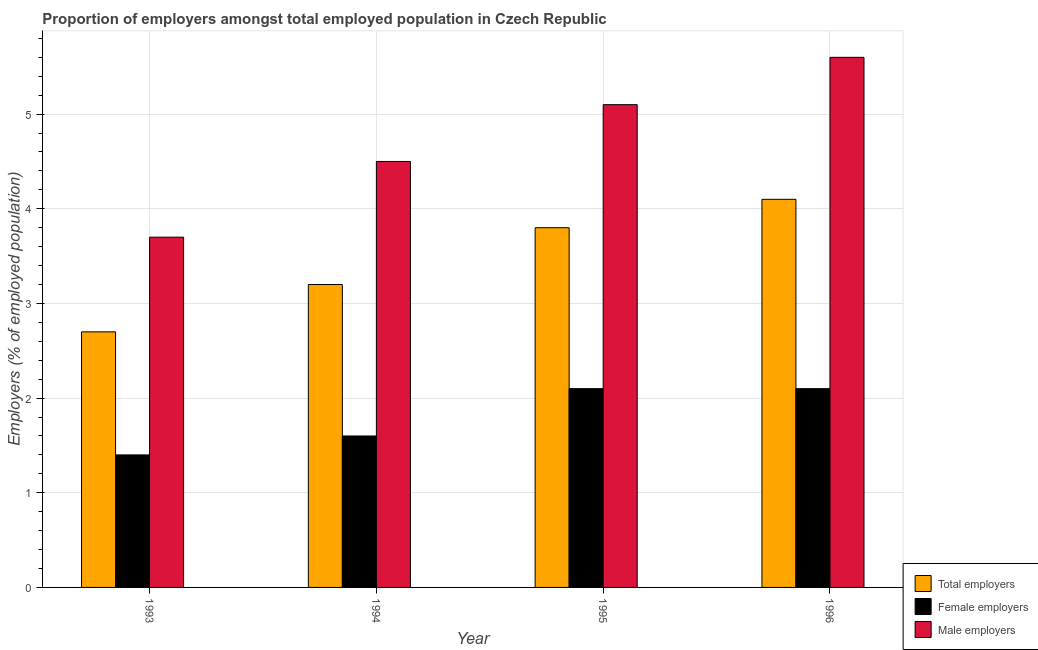How many different coloured bars are there?
Ensure brevity in your answer.  3. How many groups of bars are there?
Ensure brevity in your answer.  4. Are the number of bars per tick equal to the number of legend labels?
Provide a succinct answer. Yes. Are the number of bars on each tick of the X-axis equal?
Keep it short and to the point. Yes. How many bars are there on the 4th tick from the left?
Keep it short and to the point. 3. How many bars are there on the 3rd tick from the right?
Offer a terse response. 3. In how many cases, is the number of bars for a given year not equal to the number of legend labels?
Make the answer very short. 0. What is the percentage of total employers in 1993?
Keep it short and to the point. 2.7. Across all years, what is the maximum percentage of female employers?
Ensure brevity in your answer.  2.1. Across all years, what is the minimum percentage of female employers?
Provide a succinct answer. 1.4. In which year was the percentage of total employers maximum?
Your answer should be compact. 1996. What is the total percentage of total employers in the graph?
Provide a succinct answer. 13.8. What is the difference between the percentage of total employers in 1993 and that in 1996?
Give a very brief answer. -1.4. What is the difference between the percentage of female employers in 1996 and the percentage of total employers in 1994?
Offer a terse response. 0.5. What is the average percentage of total employers per year?
Your answer should be compact. 3.45. In how many years, is the percentage of total employers greater than 4.4 %?
Offer a very short reply. 0. What is the ratio of the percentage of male employers in 1995 to that in 1996?
Your answer should be compact. 0.91. Is the percentage of total employers in 1994 less than that in 1996?
Keep it short and to the point. Yes. Is the difference between the percentage of female employers in 1993 and 1995 greater than the difference between the percentage of male employers in 1993 and 1995?
Provide a short and direct response. No. What is the difference between the highest and the second highest percentage of total employers?
Offer a very short reply. 0.3. What is the difference between the highest and the lowest percentage of female employers?
Your response must be concise. 0.7. What does the 3rd bar from the left in 1994 represents?
Provide a succinct answer. Male employers. What does the 2nd bar from the right in 1994 represents?
Keep it short and to the point. Female employers. Is it the case that in every year, the sum of the percentage of total employers and percentage of female employers is greater than the percentage of male employers?
Offer a terse response. Yes. How many bars are there?
Provide a succinct answer. 12. How many years are there in the graph?
Keep it short and to the point. 4. Does the graph contain any zero values?
Your answer should be very brief. No. What is the title of the graph?
Make the answer very short. Proportion of employers amongst total employed population in Czech Republic. Does "Capital account" appear as one of the legend labels in the graph?
Provide a short and direct response. No. What is the label or title of the X-axis?
Your answer should be compact. Year. What is the label or title of the Y-axis?
Provide a succinct answer. Employers (% of employed population). What is the Employers (% of employed population) in Total employers in 1993?
Your response must be concise. 2.7. What is the Employers (% of employed population) in Female employers in 1993?
Your response must be concise. 1.4. What is the Employers (% of employed population) in Male employers in 1993?
Offer a very short reply. 3.7. What is the Employers (% of employed population) of Total employers in 1994?
Offer a very short reply. 3.2. What is the Employers (% of employed population) in Female employers in 1994?
Your response must be concise. 1.6. What is the Employers (% of employed population) of Male employers in 1994?
Ensure brevity in your answer.  4.5. What is the Employers (% of employed population) of Total employers in 1995?
Offer a very short reply. 3.8. What is the Employers (% of employed population) of Female employers in 1995?
Provide a succinct answer. 2.1. What is the Employers (% of employed population) in Male employers in 1995?
Offer a very short reply. 5.1. What is the Employers (% of employed population) in Total employers in 1996?
Offer a very short reply. 4.1. What is the Employers (% of employed population) of Female employers in 1996?
Offer a terse response. 2.1. What is the Employers (% of employed population) of Male employers in 1996?
Make the answer very short. 5.6. Across all years, what is the maximum Employers (% of employed population) in Total employers?
Your answer should be very brief. 4.1. Across all years, what is the maximum Employers (% of employed population) in Female employers?
Provide a succinct answer. 2.1. Across all years, what is the maximum Employers (% of employed population) in Male employers?
Give a very brief answer. 5.6. Across all years, what is the minimum Employers (% of employed population) of Total employers?
Provide a short and direct response. 2.7. Across all years, what is the minimum Employers (% of employed population) in Female employers?
Your response must be concise. 1.4. Across all years, what is the minimum Employers (% of employed population) of Male employers?
Give a very brief answer. 3.7. What is the total Employers (% of employed population) in Total employers in the graph?
Give a very brief answer. 13.8. What is the difference between the Employers (% of employed population) in Total employers in 1993 and that in 1994?
Provide a short and direct response. -0.5. What is the difference between the Employers (% of employed population) of Female employers in 1993 and that in 1994?
Keep it short and to the point. -0.2. What is the difference between the Employers (% of employed population) of Total employers in 1993 and that in 1995?
Ensure brevity in your answer.  -1.1. What is the difference between the Employers (% of employed population) in Female employers in 1994 and that in 1995?
Your response must be concise. -0.5. What is the difference between the Employers (% of employed population) of Male employers in 1994 and that in 1995?
Your answer should be compact. -0.6. What is the difference between the Employers (% of employed population) in Total employers in 1994 and that in 1996?
Keep it short and to the point. -0.9. What is the difference between the Employers (% of employed population) of Total employers in 1995 and that in 1996?
Offer a terse response. -0.3. What is the difference between the Employers (% of employed population) in Male employers in 1995 and that in 1996?
Offer a terse response. -0.5. What is the difference between the Employers (% of employed population) in Total employers in 1993 and the Employers (% of employed population) in Male employers in 1994?
Your response must be concise. -1.8. What is the difference between the Employers (% of employed population) in Total employers in 1993 and the Employers (% of employed population) in Female employers in 1995?
Keep it short and to the point. 0.6. What is the difference between the Employers (% of employed population) of Female employers in 1993 and the Employers (% of employed population) of Male employers in 1995?
Provide a succinct answer. -3.7. What is the difference between the Employers (% of employed population) of Total employers in 1993 and the Employers (% of employed population) of Female employers in 1996?
Offer a very short reply. 0.6. What is the difference between the Employers (% of employed population) in Total employers in 1993 and the Employers (% of employed population) in Male employers in 1996?
Your response must be concise. -2.9. What is the difference between the Employers (% of employed population) in Female employers in 1993 and the Employers (% of employed population) in Male employers in 1996?
Provide a succinct answer. -4.2. What is the difference between the Employers (% of employed population) in Total employers in 1994 and the Employers (% of employed population) in Female employers in 1995?
Offer a terse response. 1.1. What is the difference between the Employers (% of employed population) of Female employers in 1994 and the Employers (% of employed population) of Male employers in 1995?
Provide a succinct answer. -3.5. What is the difference between the Employers (% of employed population) in Total employers in 1994 and the Employers (% of employed population) in Male employers in 1996?
Your answer should be compact. -2.4. What is the average Employers (% of employed population) of Total employers per year?
Ensure brevity in your answer.  3.45. What is the average Employers (% of employed population) in Male employers per year?
Your response must be concise. 4.72. In the year 1993, what is the difference between the Employers (% of employed population) of Total employers and Employers (% of employed population) of Male employers?
Offer a very short reply. -1. In the year 1995, what is the difference between the Employers (% of employed population) of Total employers and Employers (% of employed population) of Female employers?
Offer a terse response. 1.7. In the year 1995, what is the difference between the Employers (% of employed population) of Female employers and Employers (% of employed population) of Male employers?
Your answer should be very brief. -3. In the year 1996, what is the difference between the Employers (% of employed population) of Total employers and Employers (% of employed population) of Male employers?
Offer a terse response. -1.5. What is the ratio of the Employers (% of employed population) in Total employers in 1993 to that in 1994?
Your answer should be very brief. 0.84. What is the ratio of the Employers (% of employed population) of Male employers in 1993 to that in 1994?
Provide a short and direct response. 0.82. What is the ratio of the Employers (% of employed population) in Total employers in 1993 to that in 1995?
Offer a very short reply. 0.71. What is the ratio of the Employers (% of employed population) in Female employers in 1993 to that in 1995?
Your answer should be compact. 0.67. What is the ratio of the Employers (% of employed population) in Male employers in 1993 to that in 1995?
Ensure brevity in your answer.  0.73. What is the ratio of the Employers (% of employed population) in Total employers in 1993 to that in 1996?
Provide a short and direct response. 0.66. What is the ratio of the Employers (% of employed population) in Male employers in 1993 to that in 1996?
Your answer should be compact. 0.66. What is the ratio of the Employers (% of employed population) of Total employers in 1994 to that in 1995?
Your answer should be very brief. 0.84. What is the ratio of the Employers (% of employed population) in Female employers in 1994 to that in 1995?
Offer a very short reply. 0.76. What is the ratio of the Employers (% of employed population) of Male employers in 1994 to that in 1995?
Your response must be concise. 0.88. What is the ratio of the Employers (% of employed population) in Total employers in 1994 to that in 1996?
Keep it short and to the point. 0.78. What is the ratio of the Employers (% of employed population) of Female employers in 1994 to that in 1996?
Give a very brief answer. 0.76. What is the ratio of the Employers (% of employed population) of Male employers in 1994 to that in 1996?
Offer a very short reply. 0.8. What is the ratio of the Employers (% of employed population) in Total employers in 1995 to that in 1996?
Your response must be concise. 0.93. What is the ratio of the Employers (% of employed population) of Male employers in 1995 to that in 1996?
Keep it short and to the point. 0.91. What is the difference between the highest and the second highest Employers (% of employed population) of Total employers?
Your answer should be compact. 0.3. What is the difference between the highest and the lowest Employers (% of employed population) in Female employers?
Provide a succinct answer. 0.7. What is the difference between the highest and the lowest Employers (% of employed population) of Male employers?
Your response must be concise. 1.9. 